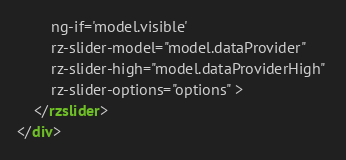<code> <loc_0><loc_0><loc_500><loc_500><_HTML_>		ng-if='model.visible' 
		rz-slider-model="model.dataProvider" 
		rz-slider-high="model.dataProviderHigh" 
		rz-slider-options="options" >
	</rzslider>
</div></code> 